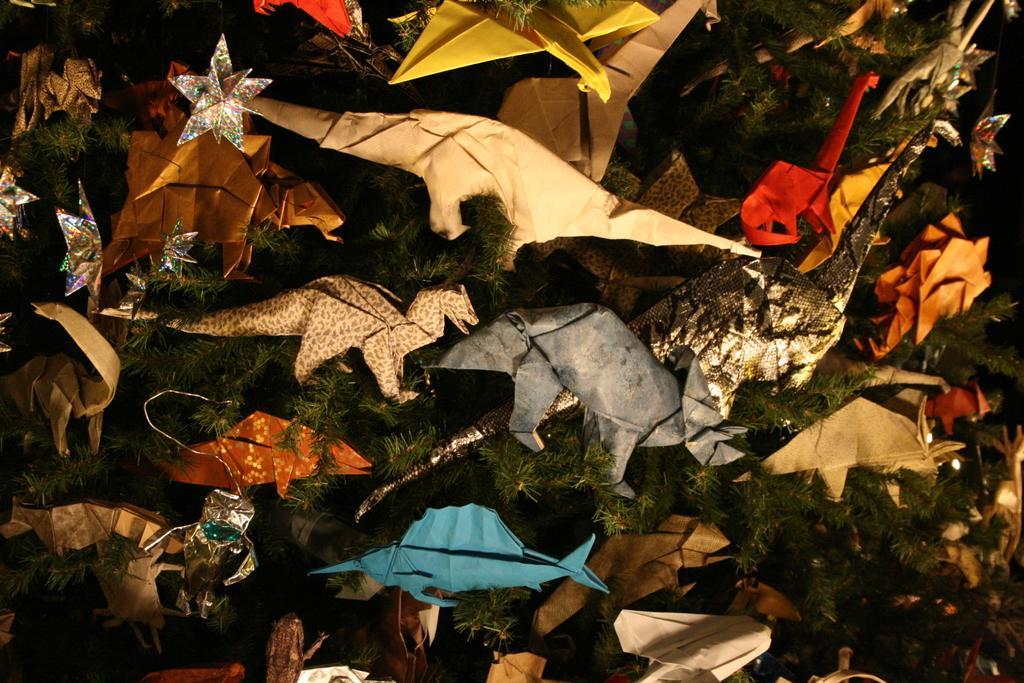Could you give a brief overview of what you see in this image? In this image we can see stars and paper toys on a plant. 